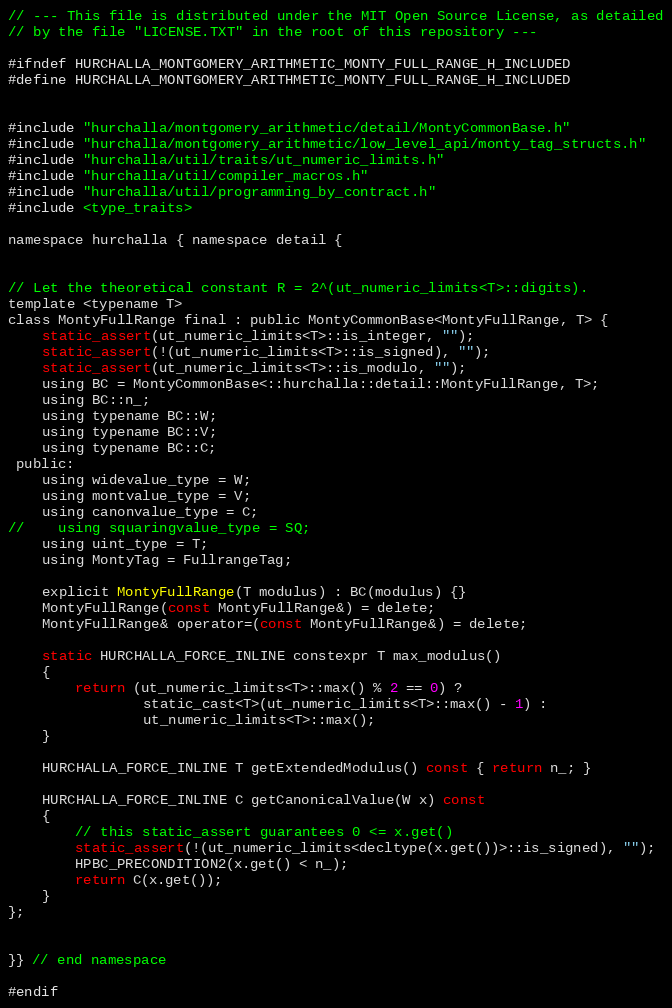<code> <loc_0><loc_0><loc_500><loc_500><_C_>// --- This file is distributed under the MIT Open Source License, as detailed
// by the file "LICENSE.TXT" in the root of this repository ---

#ifndef HURCHALLA_MONTGOMERY_ARITHMETIC_MONTY_FULL_RANGE_H_INCLUDED
#define HURCHALLA_MONTGOMERY_ARITHMETIC_MONTY_FULL_RANGE_H_INCLUDED


#include "hurchalla/montgomery_arithmetic/detail/MontyCommonBase.h"
#include "hurchalla/montgomery_arithmetic/low_level_api/monty_tag_structs.h"
#include "hurchalla/util/traits/ut_numeric_limits.h"
#include "hurchalla/util/compiler_macros.h"
#include "hurchalla/util/programming_by_contract.h"
#include <type_traits>

namespace hurchalla { namespace detail {


// Let the theoretical constant R = 2^(ut_numeric_limits<T>::digits).
template <typename T>
class MontyFullRange final : public MontyCommonBase<MontyFullRange, T> {
    static_assert(ut_numeric_limits<T>::is_integer, "");
    static_assert(!(ut_numeric_limits<T>::is_signed), "");
    static_assert(ut_numeric_limits<T>::is_modulo, "");
    using BC = MontyCommonBase<::hurchalla::detail::MontyFullRange, T>;
    using BC::n_;
    using typename BC::W;
    using typename BC::V;
    using typename BC::C;
 public:
    using widevalue_type = W;
    using montvalue_type = V;
    using canonvalue_type = C;
//    using squaringvalue_type = SQ;
    using uint_type = T;
    using MontyTag = FullrangeTag;

    explicit MontyFullRange(T modulus) : BC(modulus) {}
    MontyFullRange(const MontyFullRange&) = delete;
    MontyFullRange& operator=(const MontyFullRange&) = delete;

    static HURCHALLA_FORCE_INLINE constexpr T max_modulus()
    {
        return (ut_numeric_limits<T>::max() % 2 == 0) ?
                static_cast<T>(ut_numeric_limits<T>::max() - 1) :
                ut_numeric_limits<T>::max();
    }

    HURCHALLA_FORCE_INLINE T getExtendedModulus() const { return n_; }

    HURCHALLA_FORCE_INLINE C getCanonicalValue(W x) const
    {
        // this static_assert guarantees 0 <= x.get()
        static_assert(!(ut_numeric_limits<decltype(x.get())>::is_signed), "");
        HPBC_PRECONDITION2(x.get() < n_);
        return C(x.get());
    }
};


}} // end namespace

#endif
</code> 